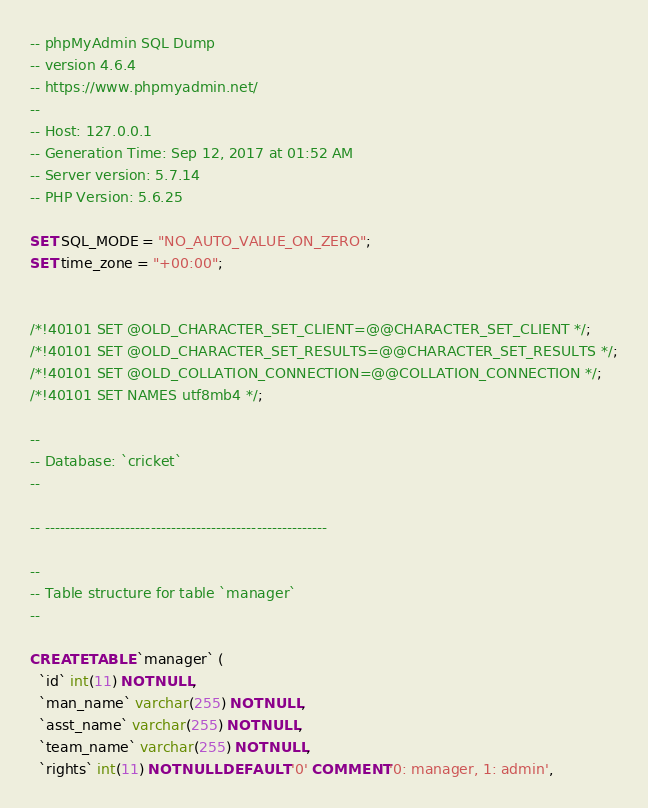<code> <loc_0><loc_0><loc_500><loc_500><_SQL_>-- phpMyAdmin SQL Dump
-- version 4.6.4
-- https://www.phpmyadmin.net/
--
-- Host: 127.0.0.1
-- Generation Time: Sep 12, 2017 at 01:52 AM
-- Server version: 5.7.14
-- PHP Version: 5.6.25

SET SQL_MODE = "NO_AUTO_VALUE_ON_ZERO";
SET time_zone = "+00:00";


/*!40101 SET @OLD_CHARACTER_SET_CLIENT=@@CHARACTER_SET_CLIENT */;
/*!40101 SET @OLD_CHARACTER_SET_RESULTS=@@CHARACTER_SET_RESULTS */;
/*!40101 SET @OLD_COLLATION_CONNECTION=@@COLLATION_CONNECTION */;
/*!40101 SET NAMES utf8mb4 */;

--
-- Database: `cricket`
--

-- --------------------------------------------------------

--
-- Table structure for table `manager`
--

CREATE TABLE `manager` (
  `id` int(11) NOT NULL,
  `man_name` varchar(255) NOT NULL,
  `asst_name` varchar(255) NOT NULL,
  `team_name` varchar(255) NOT NULL,
  `rights` int(11) NOT NULL DEFAULT '0' COMMENT '0: manager, 1: admin',</code> 